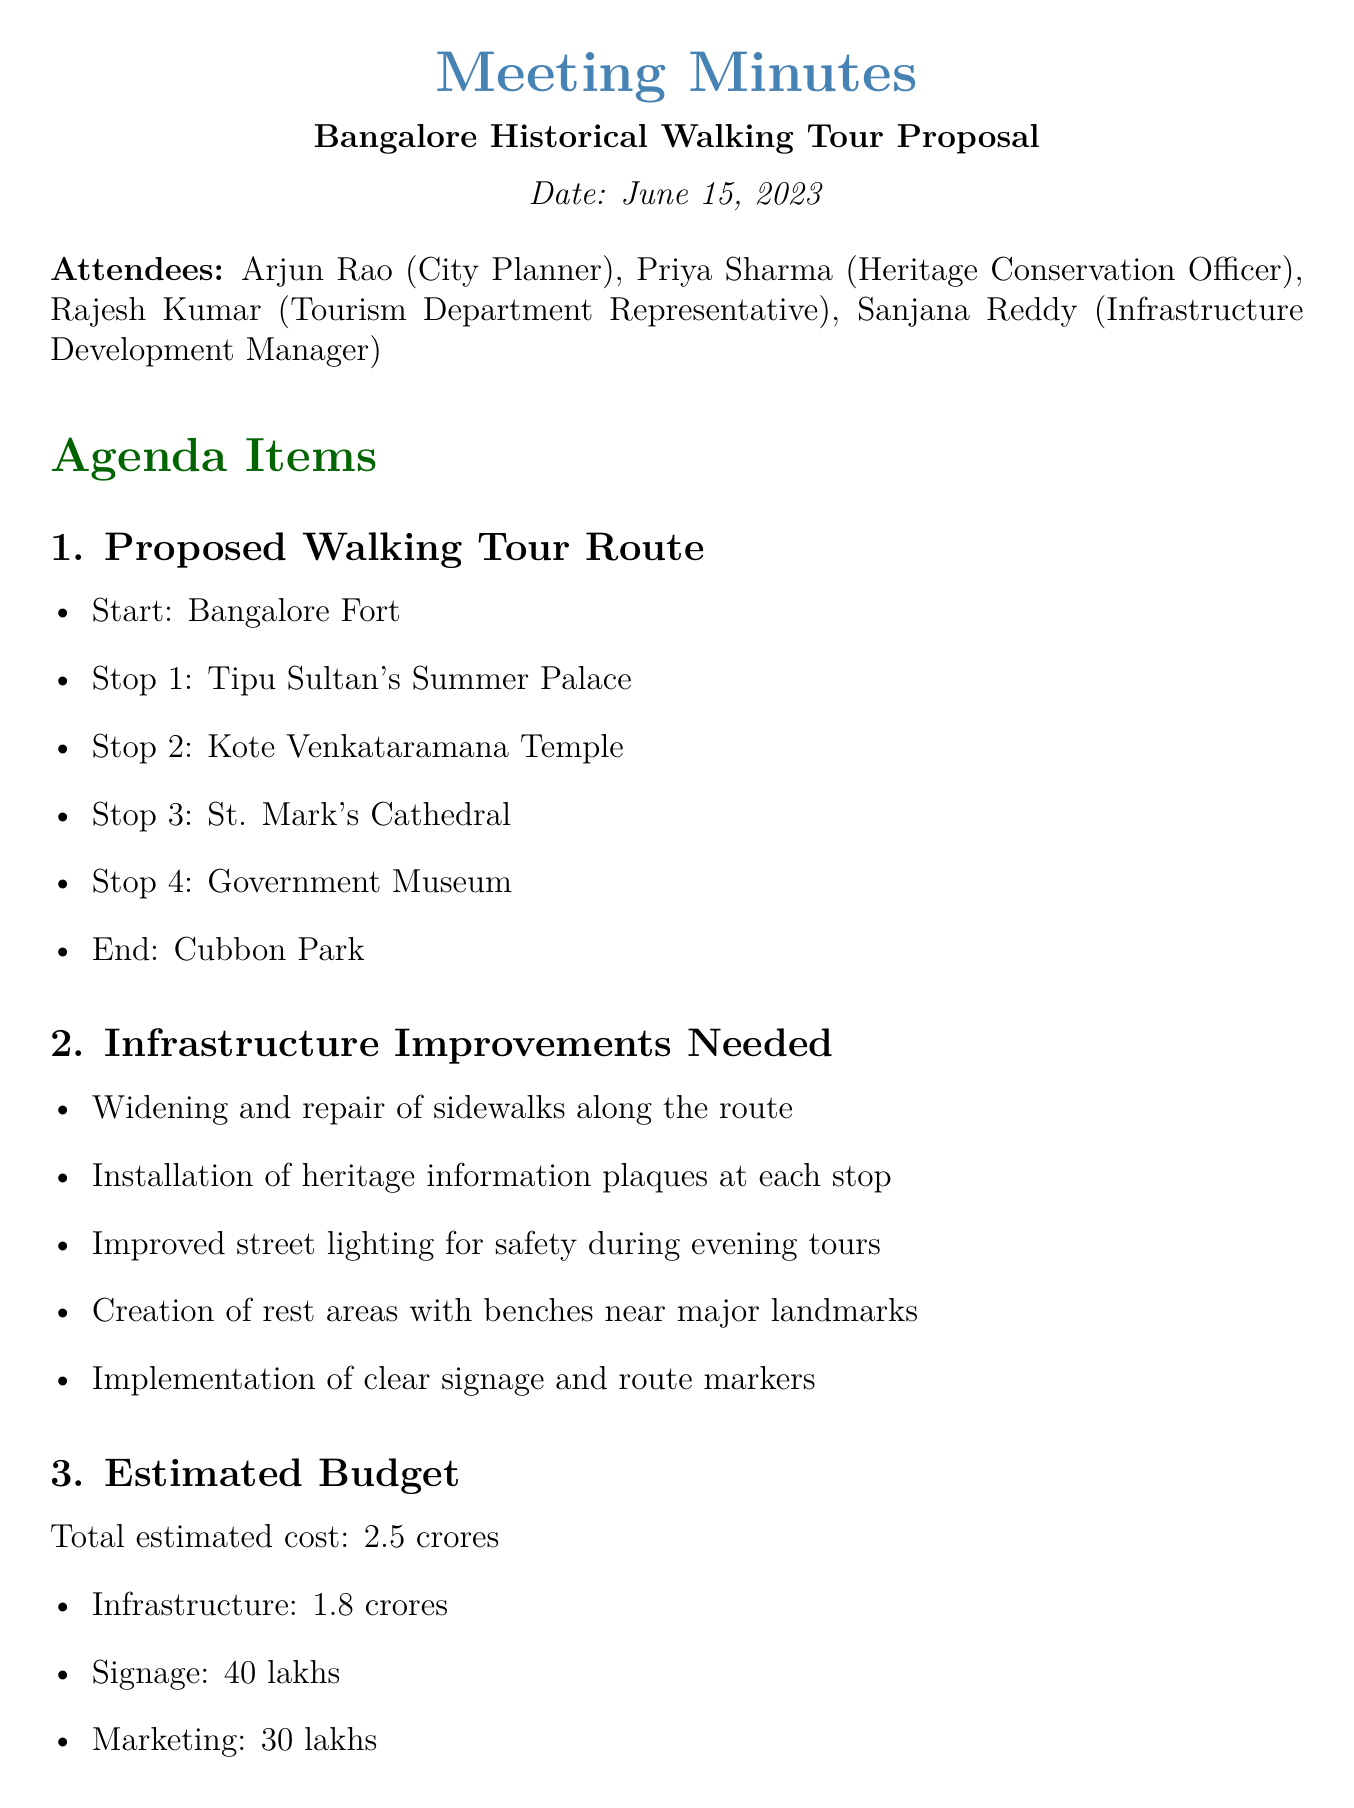What is the date of the meeting? The date of the meeting is specified at the beginning of the document.
Answer: June 15, 2023 Who is the City Planner? The City Planner is listed among the attendees of the meeting.
Answer: Arjun Rao What is the estimated total cost for the project? The total estimated cost is mentioned in the budget section of the document.
Answer: ₹2.5 crores How many months are allocated for infrastructure improvements? The timeline section specifies the duration required for infrastructure improvements.
Answer: 6 months Which landmark is the starting point of the proposed walking tour? The proposed walking tour route lists the starting point at the beginning.
Answer: Bangalore Fort What are the improvements needed for street safety during evening tours? The document discusses infrastructure improvements for safety measures.
Answer: Improved street lighting Who will oversee the development of historical content for the plaques? The action items indicate the person responsible for this task.
Answer: Priya What is the launch date of the walking tour? The timeline section provides information on the estimated launch date of the project.
Answer: April 2024 What organization is suggested for promotion of the walking tour? The potential partnerships section lists organizations involved in the project.
Answer: Karnataka Tourism Board 